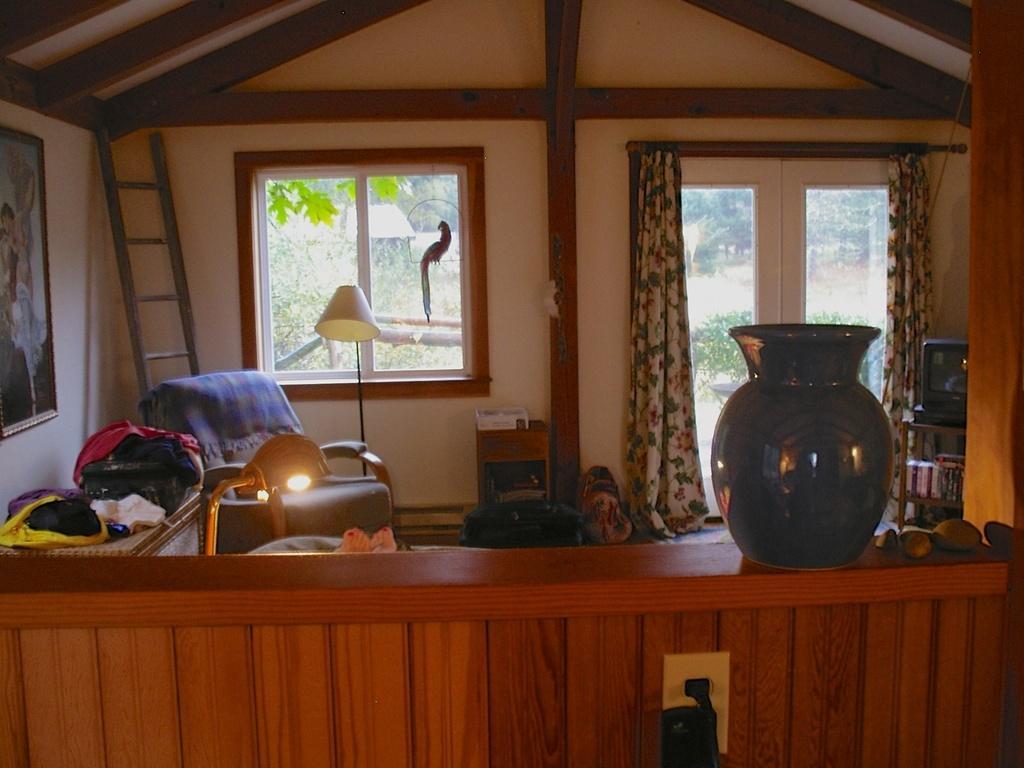Could you give a brief overview of what you see in this image? This picture is clicked in a room. Towards the right there is a jar, stones, television and a curtain. Towards the left there is frame, ladder, table, chair and a lamp. In the center there is a window and a bird. Through the window there are some plants. 